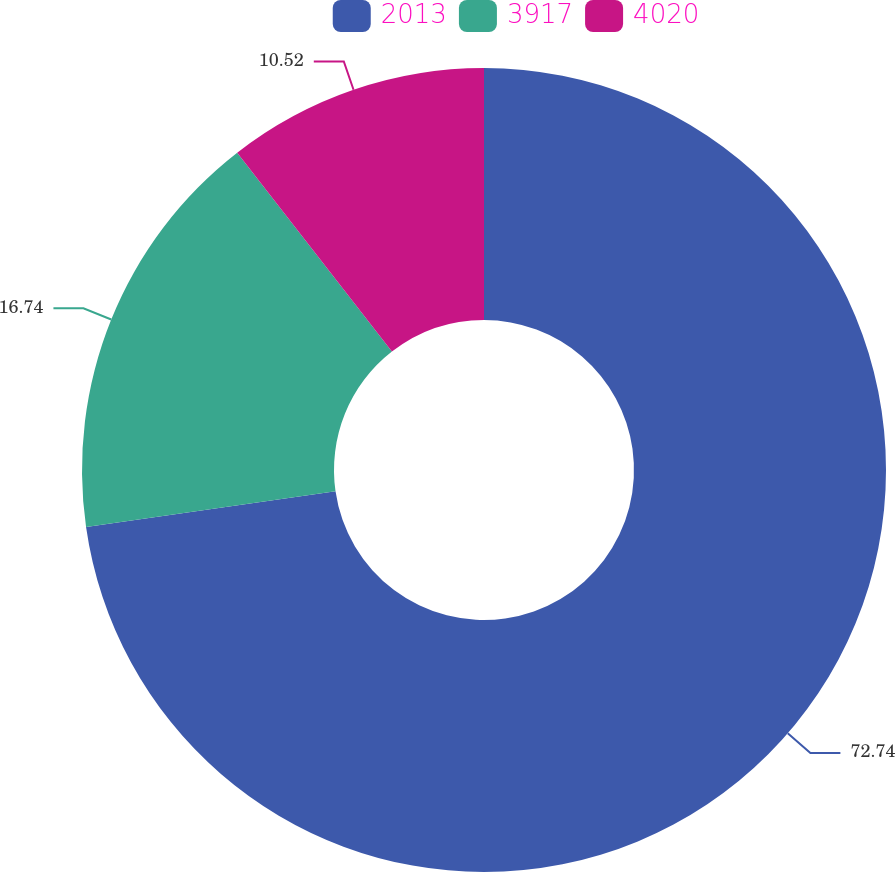Convert chart. <chart><loc_0><loc_0><loc_500><loc_500><pie_chart><fcel>2013<fcel>3917<fcel>4020<nl><fcel>72.73%<fcel>16.74%<fcel>10.52%<nl></chart> 